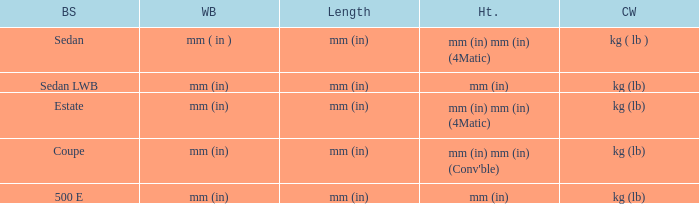What's the curb weight of the model with a wheelbase of mm (in) and height of mm (in) mm (in) (4Matic)? Kg ( lb ), kg (lb). 